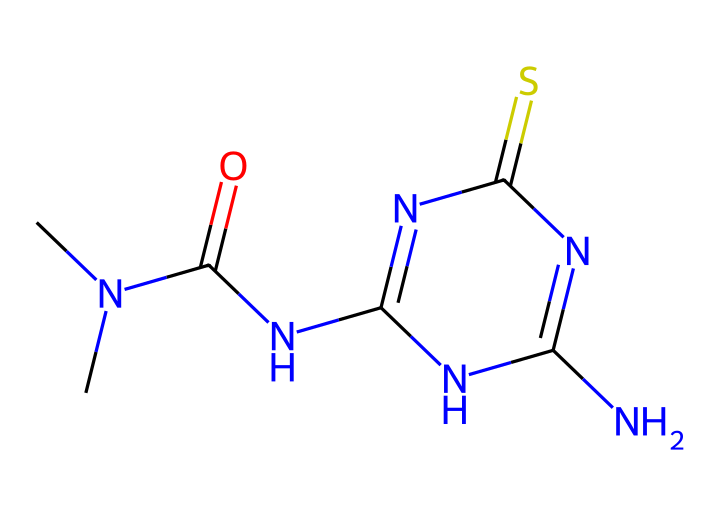What is the main functional group present in thidiazuron? The chemical structure contains an amide functional group (–C(=O)N–) between the carbon and nitrogen, which characterizes amides.
Answer: amide How many nitrogen atoms are in thidiazuron? By analyzing the structure, we can count a total of four nitrogen atoms: one in the amide group and three in the ring structure.
Answer: 4 Is thidiazuron a solid, liquid, or gas at room temperature? Based on its structure and typical properties of similar compounds, thidiazuron is usually found in solid form at room temperature.
Answer: solid What is the molecular formula of thidiazuron? By interpreting the SMILES representation, the molecular formula can be deduced as C8H10N4O1S1.
Answer: C8H10N4OS Which part of this chemical is responsible for its plant growth regulation ability? The nitrogen-containing heterocyclic ring contributes to its activity as a cytokinin-like regulator, influencing plant growth and development.
Answer: nitrogen-containing ring What type of compound is thidiazuron classified as? Thidiazuron, based on its structure featuring hydrazine derivatives and functional groups typical of cytokinins, is classified as a plant growth regulator.
Answer: plant growth regulator How many total atoms are there in thidiazuron? The chemical structure can be summarized: 8 carbons, 10 hydrogens, 4 nitrogens, 1 sulfur, and 1 oxygen, resulting in a total of 24 atoms.
Answer: 24 